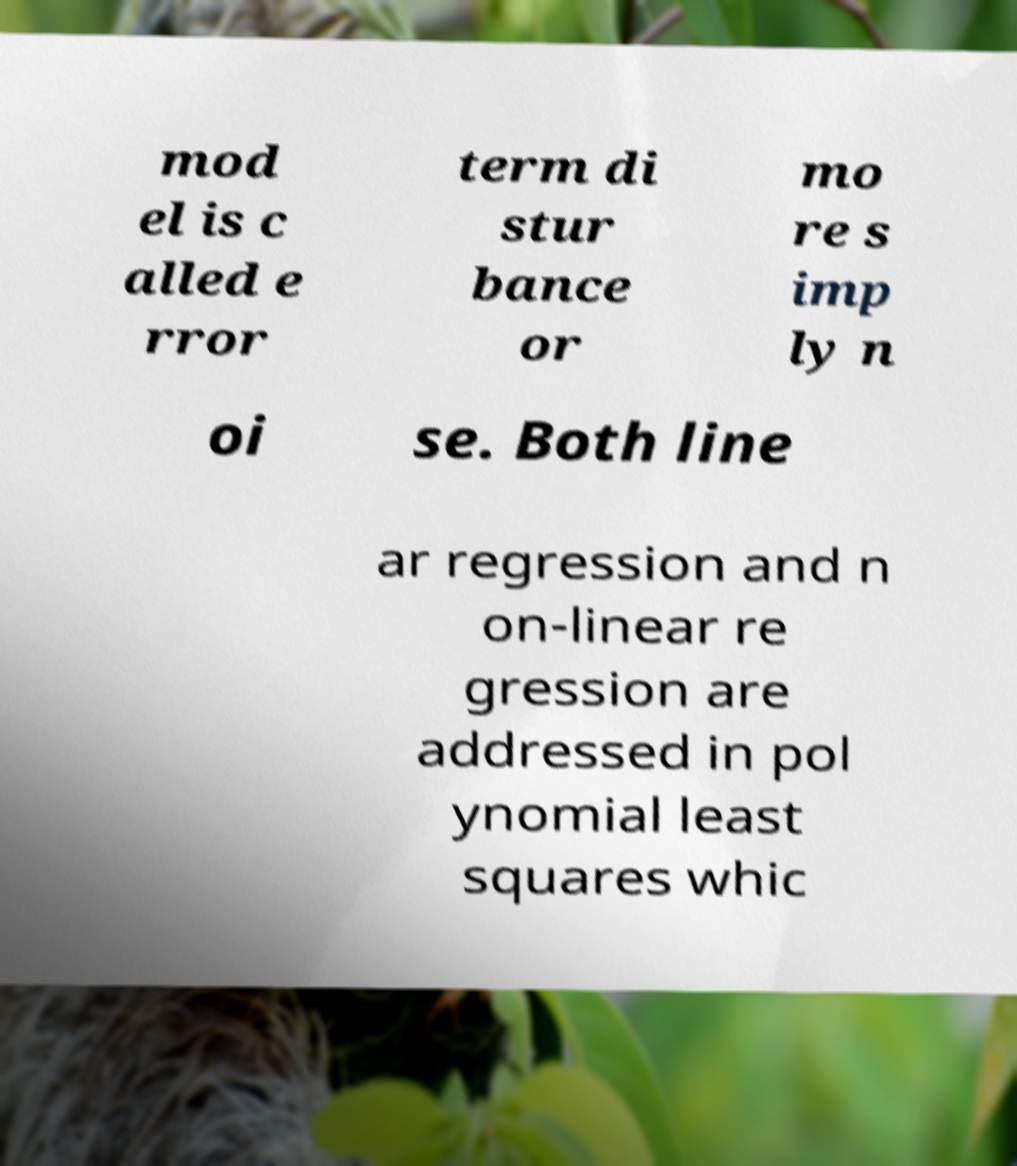I need the written content from this picture converted into text. Can you do that? mod el is c alled e rror term di stur bance or mo re s imp ly n oi se. Both line ar regression and n on-linear re gression are addressed in pol ynomial least squares whic 